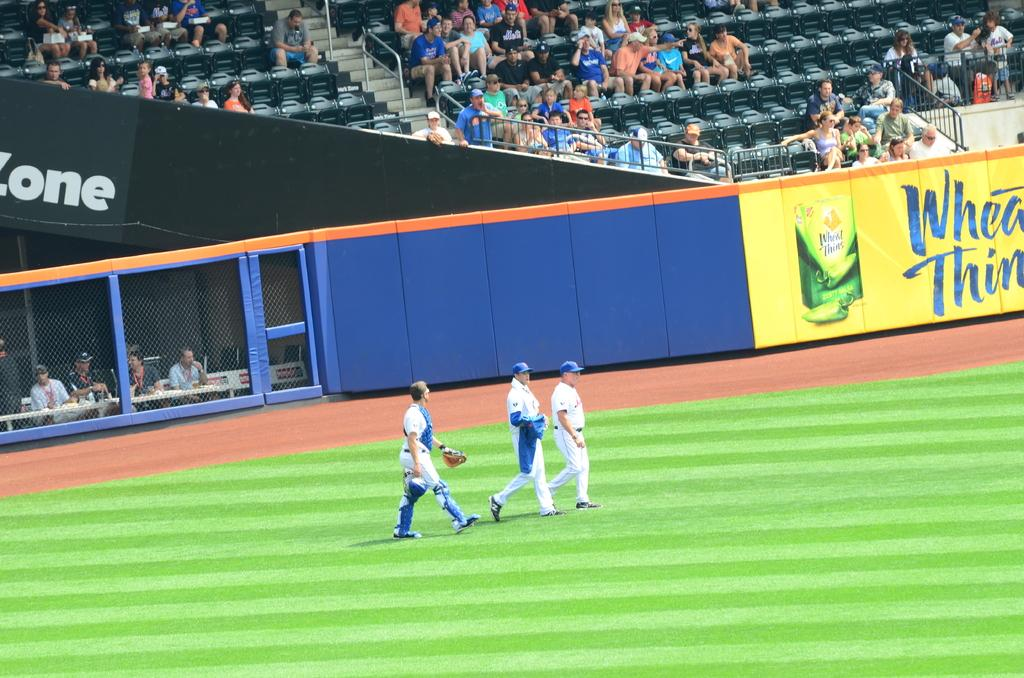<image>
Share a concise interpretation of the image provided. A Wheat Thins advertisement covers a section of the wall of a baseball stadium. 